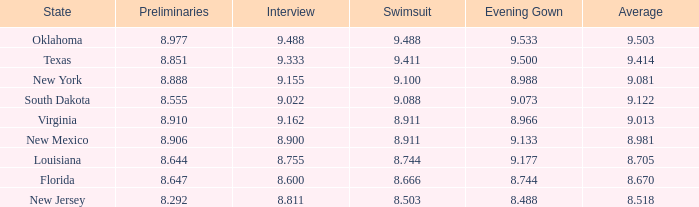What's the beginning phase where the state is south dakota? 8.555. 